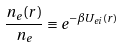<formula> <loc_0><loc_0><loc_500><loc_500>\frac { n _ { e } ( r ) } { n _ { e } } \equiv e ^ { - \beta U _ { e i } ( r ) }</formula> 